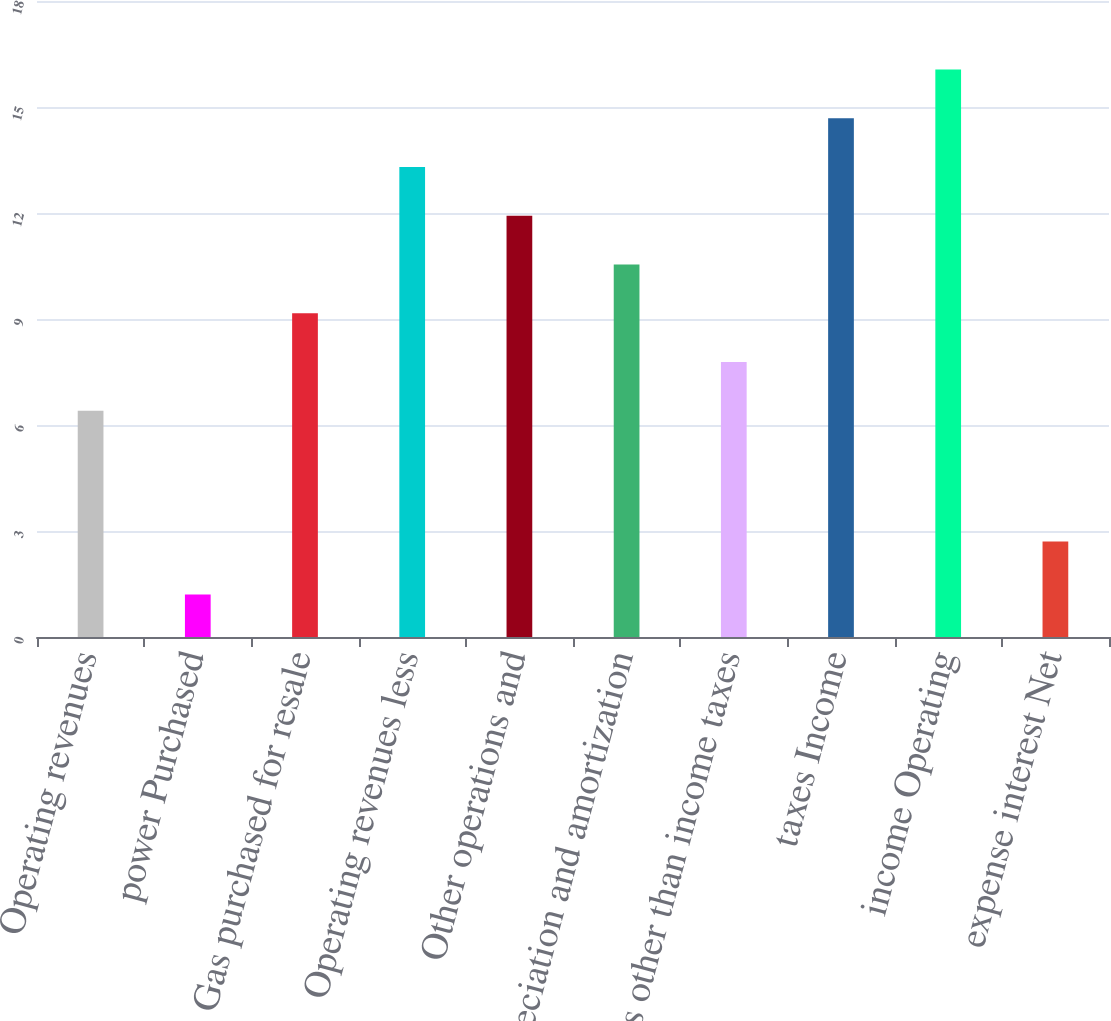<chart> <loc_0><loc_0><loc_500><loc_500><bar_chart><fcel>Operating revenues<fcel>power Purchased<fcel>Gas purchased for resale<fcel>Operating revenues less<fcel>Other operations and<fcel>Depreciation and amortization<fcel>Taxes other than income taxes<fcel>taxes Income<fcel>income Operating<fcel>expense interest Net<nl><fcel>6.4<fcel>1.2<fcel>9.16<fcel>13.3<fcel>11.92<fcel>10.54<fcel>7.78<fcel>14.68<fcel>16.06<fcel>2.7<nl></chart> 